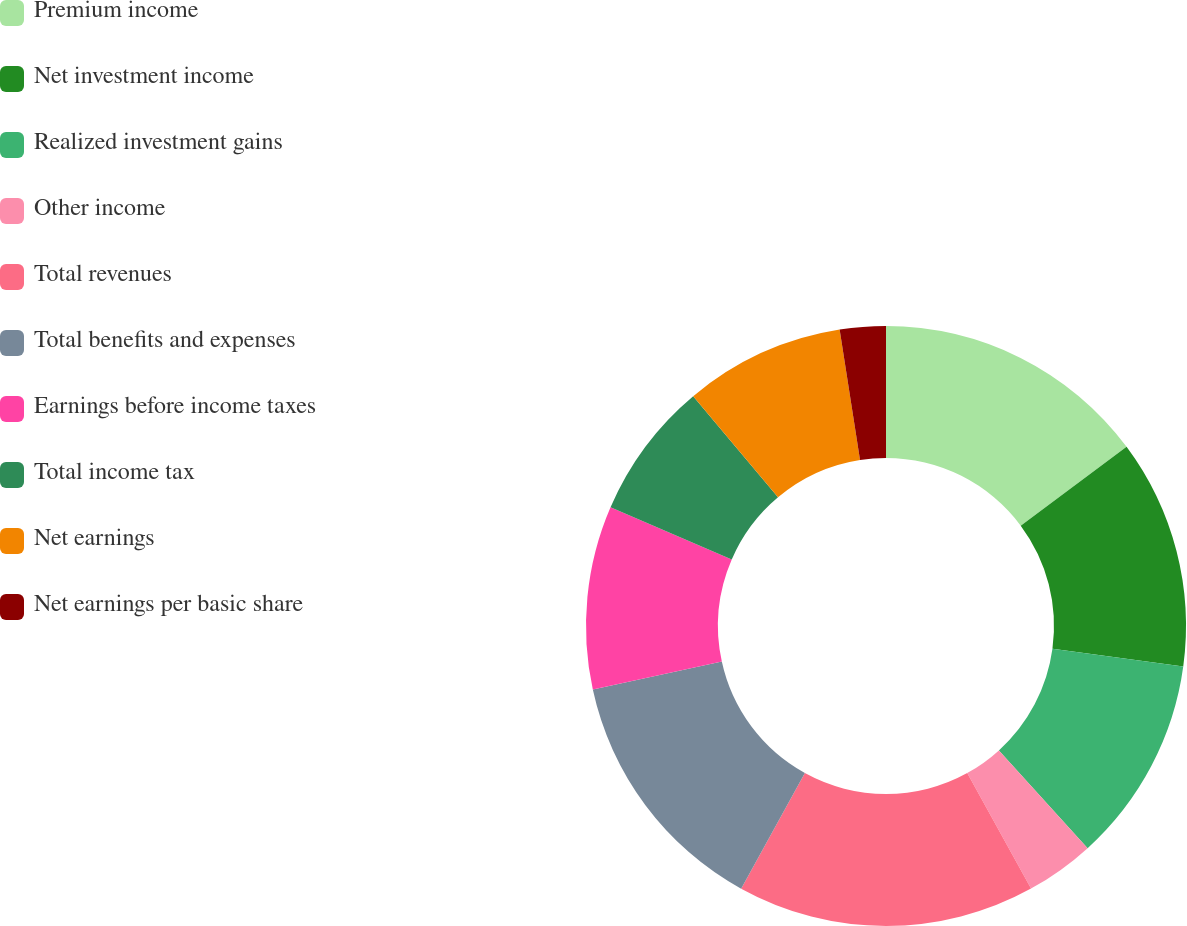Convert chart. <chart><loc_0><loc_0><loc_500><loc_500><pie_chart><fcel>Premium income<fcel>Net investment income<fcel>Realized investment gains<fcel>Other income<fcel>Total revenues<fcel>Total benefits and expenses<fcel>Earnings before income taxes<fcel>Total income tax<fcel>Net earnings<fcel>Net earnings per basic share<nl><fcel>14.81%<fcel>12.35%<fcel>11.11%<fcel>3.7%<fcel>16.05%<fcel>13.58%<fcel>9.88%<fcel>7.41%<fcel>8.64%<fcel>2.47%<nl></chart> 